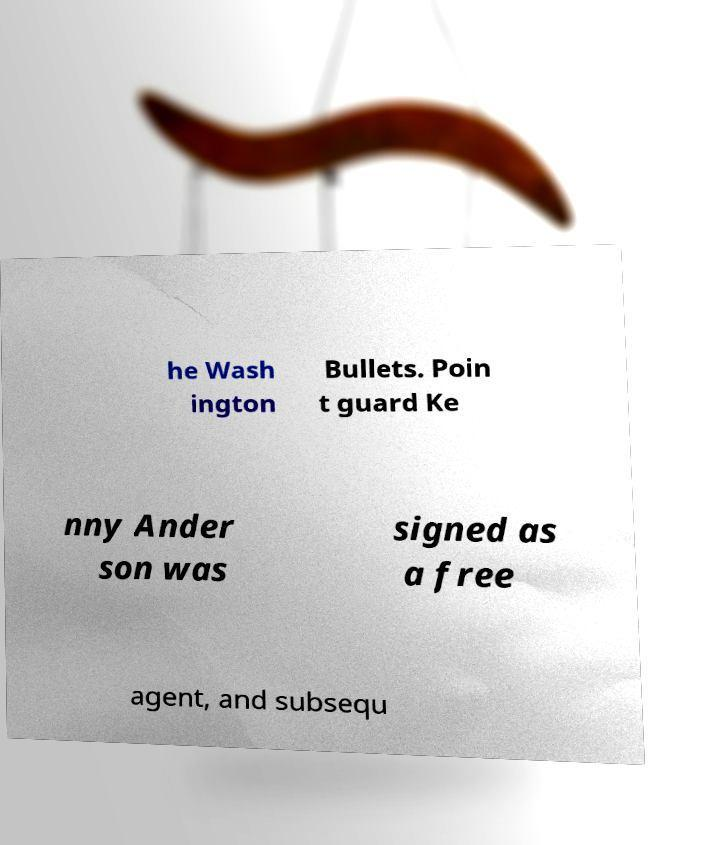Please read and relay the text visible in this image. What does it say? he Wash ington Bullets. Poin t guard Ke nny Ander son was signed as a free agent, and subsequ 